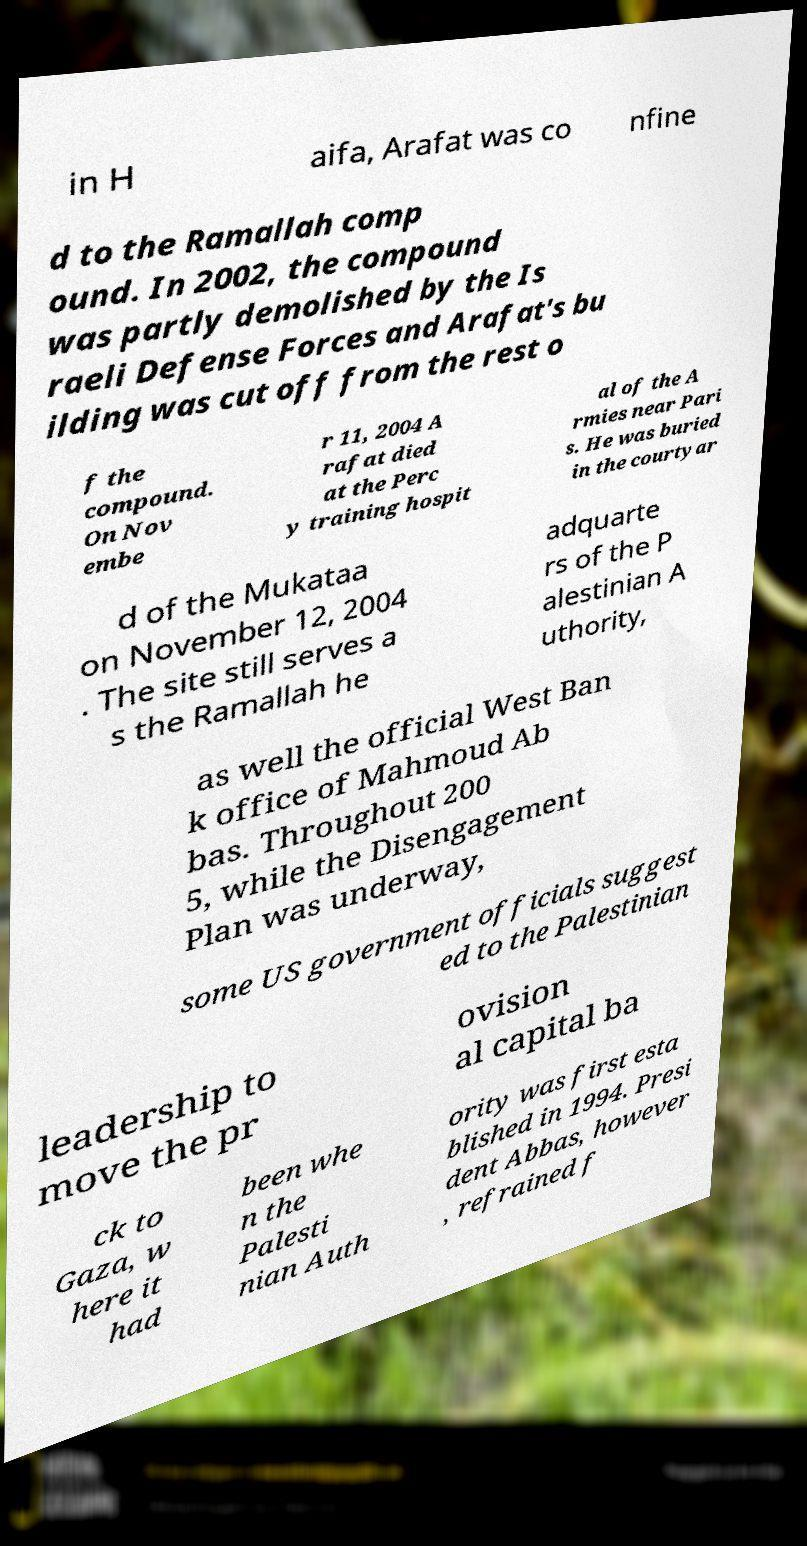Please identify and transcribe the text found in this image. in H aifa, Arafat was co nfine d to the Ramallah comp ound. In 2002, the compound was partly demolished by the Is raeli Defense Forces and Arafat's bu ilding was cut off from the rest o f the compound. On Nov embe r 11, 2004 A rafat died at the Perc y training hospit al of the A rmies near Pari s. He was buried in the courtyar d of the Mukataa on November 12, 2004 . The site still serves a s the Ramallah he adquarte rs of the P alestinian A uthority, as well the official West Ban k office of Mahmoud Ab bas. Throughout 200 5, while the Disengagement Plan was underway, some US government officials suggest ed to the Palestinian leadership to move the pr ovision al capital ba ck to Gaza, w here it had been whe n the Palesti nian Auth ority was first esta blished in 1994. Presi dent Abbas, however , refrained f 